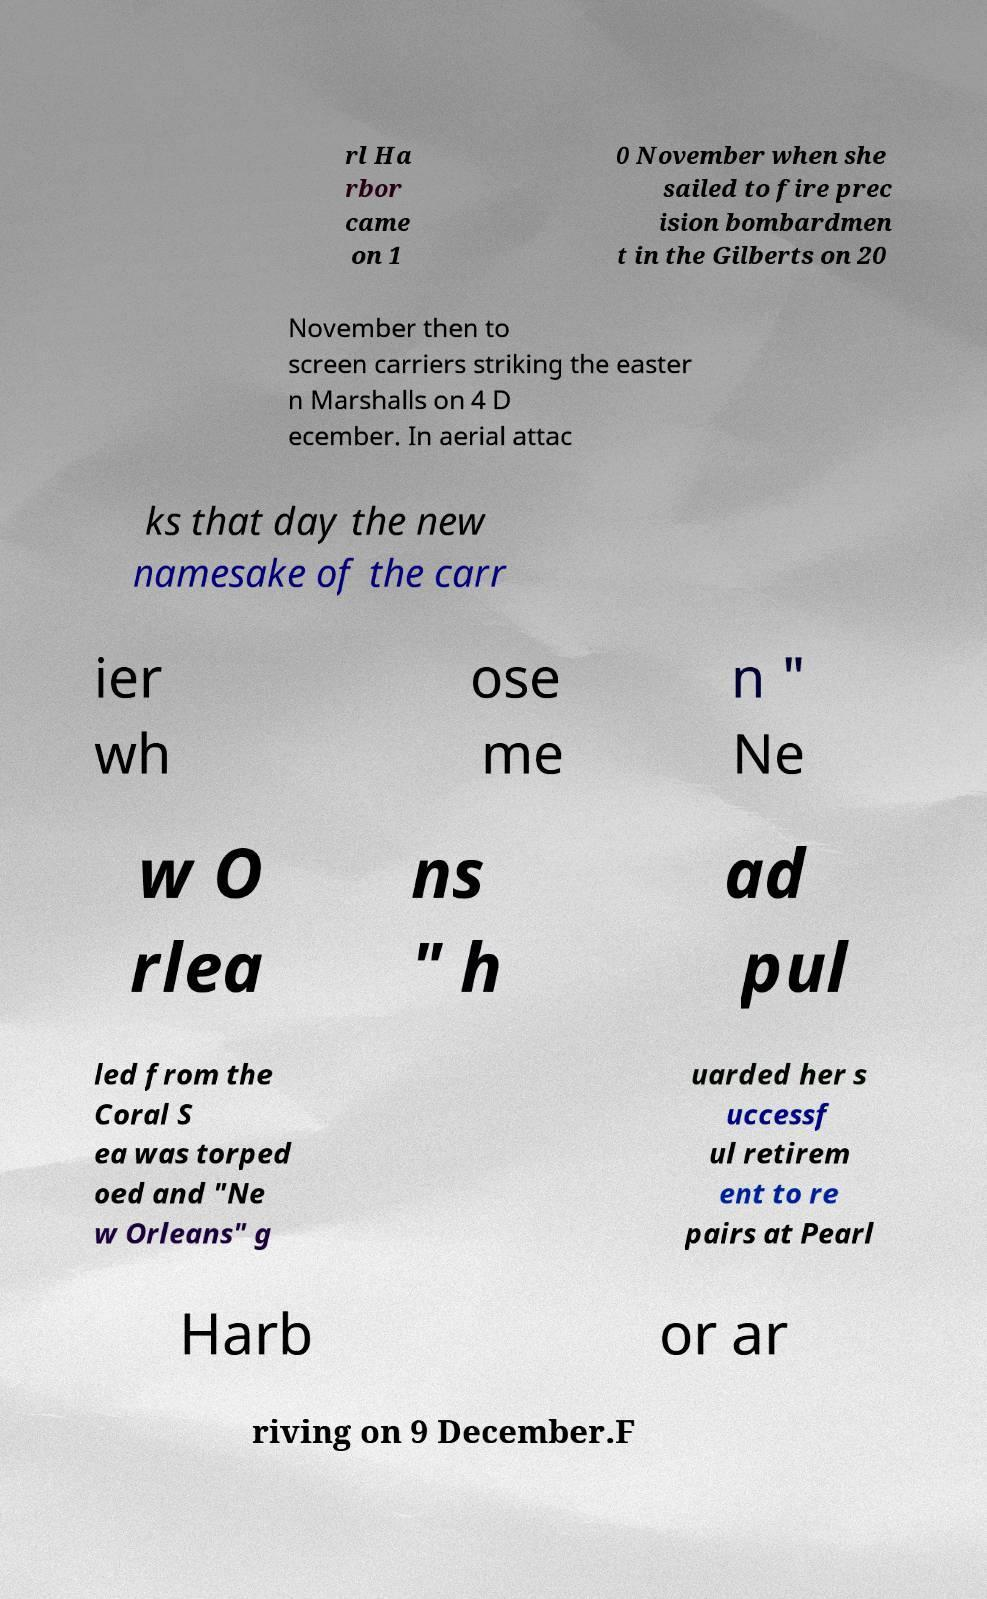Could you extract and type out the text from this image? rl Ha rbor came on 1 0 November when she sailed to fire prec ision bombardmen t in the Gilberts on 20 November then to screen carriers striking the easter n Marshalls on 4 D ecember. In aerial attac ks that day the new namesake of the carr ier wh ose me n " Ne w O rlea ns " h ad pul led from the Coral S ea was torped oed and "Ne w Orleans" g uarded her s uccessf ul retirem ent to re pairs at Pearl Harb or ar riving on 9 December.F 